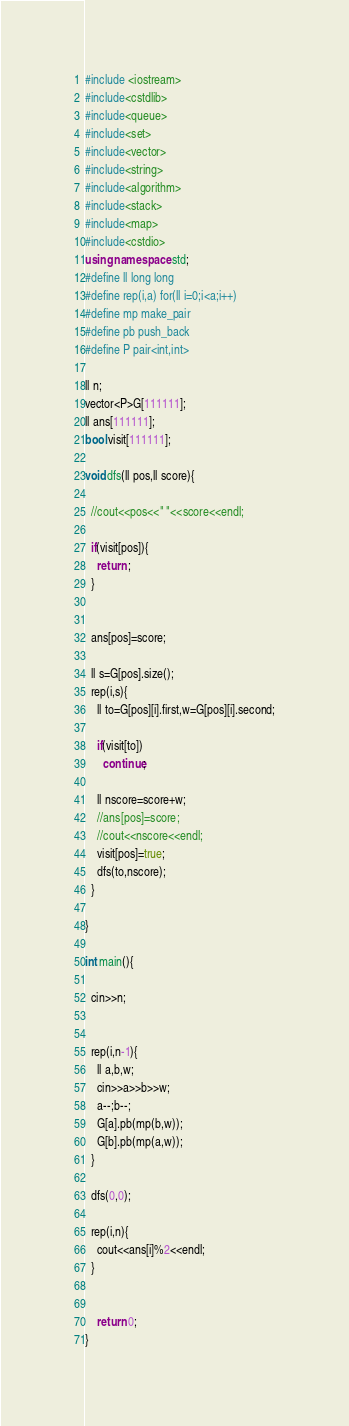Convert code to text. <code><loc_0><loc_0><loc_500><loc_500><_C++_>#include <iostream>
#include<cstdlib>
#include<queue>
#include<set>
#include<vector>
#include<string>
#include<algorithm>
#include<stack>
#include<map>
#include<cstdio>
using namespace std;
#define ll long long
#define rep(i,a) for(ll i=0;i<a;i++)
#define mp make_pair
#define pb push_back
#define P pair<int,int>

ll n;
vector<P>G[111111];
ll ans[111111];
bool visit[111111];

void dfs(ll pos,ll score){
  
  //cout<<pos<<" "<<score<<endl;

  if(visit[pos]){
    return ;
  }


  ans[pos]=score;

  ll s=G[pos].size();
  rep(i,s){
    ll to=G[pos][i].first,w=G[pos][i].second;

    if(visit[to])
      continue;
    
    ll nscore=score+w;
    //ans[pos]=score;
    //cout<<nscore<<endl;
    visit[pos]=true;
    dfs(to,nscore);
  }

}

int main(){

  cin>>n;


  rep(i,n-1){
    ll a,b,w;
    cin>>a>>b>>w;
    a--;b--;
    G[a].pb(mp(b,w));
    G[b].pb(mp(a,w));
  }

  dfs(0,0);

  rep(i,n){
    cout<<ans[i]%2<<endl;
  }


	return 0;
}
</code> 